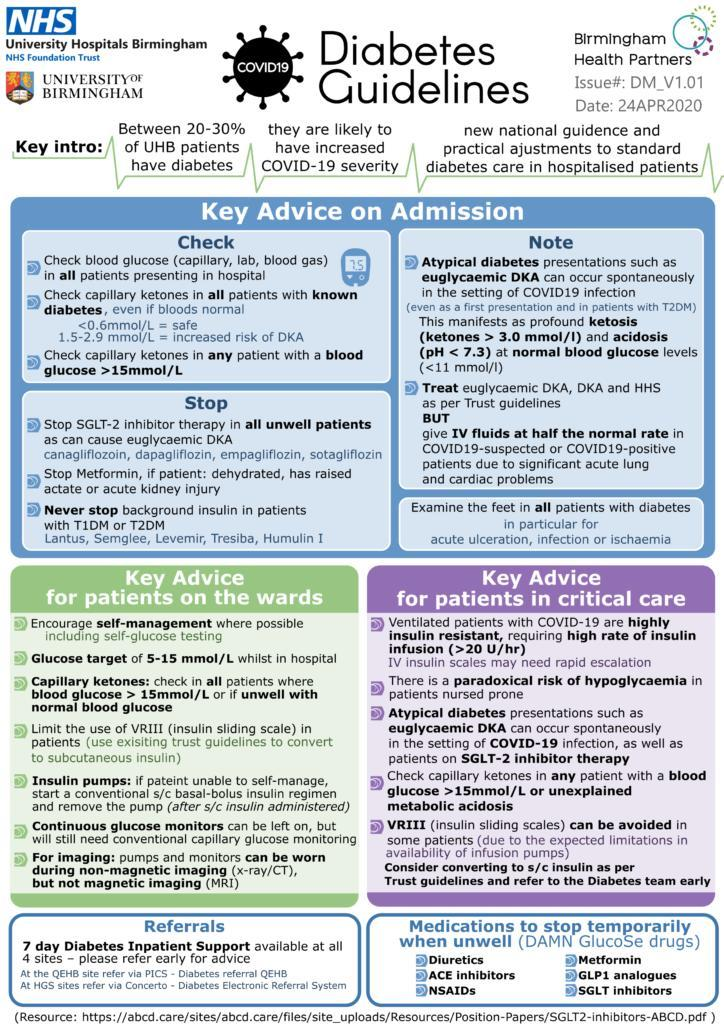what can be included to encourage self-management in patients?
Answer the question with a short phrase. self-glucose testing What percentage of the patients at UHB have diabetes? 20-30% What symptoms might be seen in the feet of diabetic patients? acute ulceration, infection or ischaemia Which disease is likely to increase covid-19 severity? diabetes 